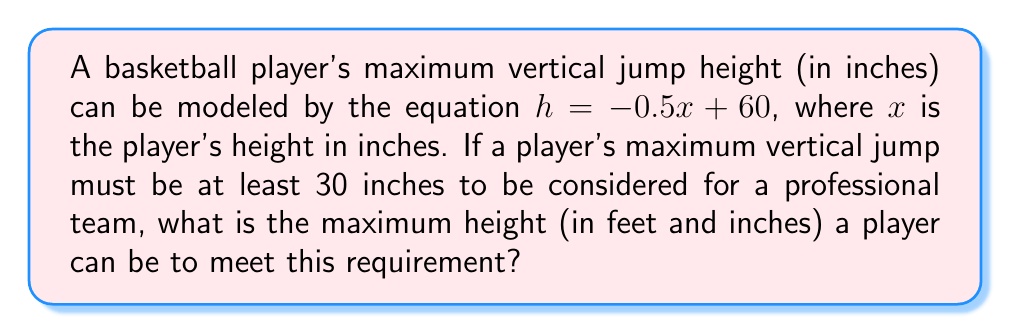Show me your answer to this math problem. 1) We start with the equation: $h = -0.5x + 60$

2) We know that the minimum acceptable jump height is 30 inches. Let's substitute this into our equation:
   $30 = -0.5x + 60$

3) Now, we solve for $x$:
   $30 - 60 = -0.5x$
   $-30 = -0.5x$

4) Divide both sides by -0.5:
   $\frac{-30}{-0.5} = x$
   $60 = x$

5) This means the maximum height in inches is 60 inches.

6) To convert 60 inches to feet and inches:
   60 ÷ 12 = 5 remainder 0

Therefore, 60 inches is equivalent to 5 feet 0 inches.
Answer: 5'0" 